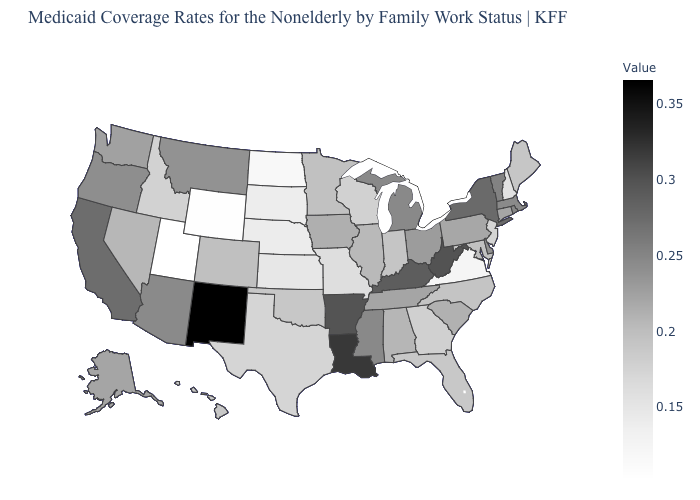Does New York have a lower value than Hawaii?
Answer briefly. No. Does the map have missing data?
Concise answer only. No. Does the map have missing data?
Give a very brief answer. No. Which states have the lowest value in the MidWest?
Concise answer only. North Dakota. Among the states that border Arizona , which have the lowest value?
Concise answer only. Utah. Which states have the highest value in the USA?
Write a very short answer. New Mexico. 